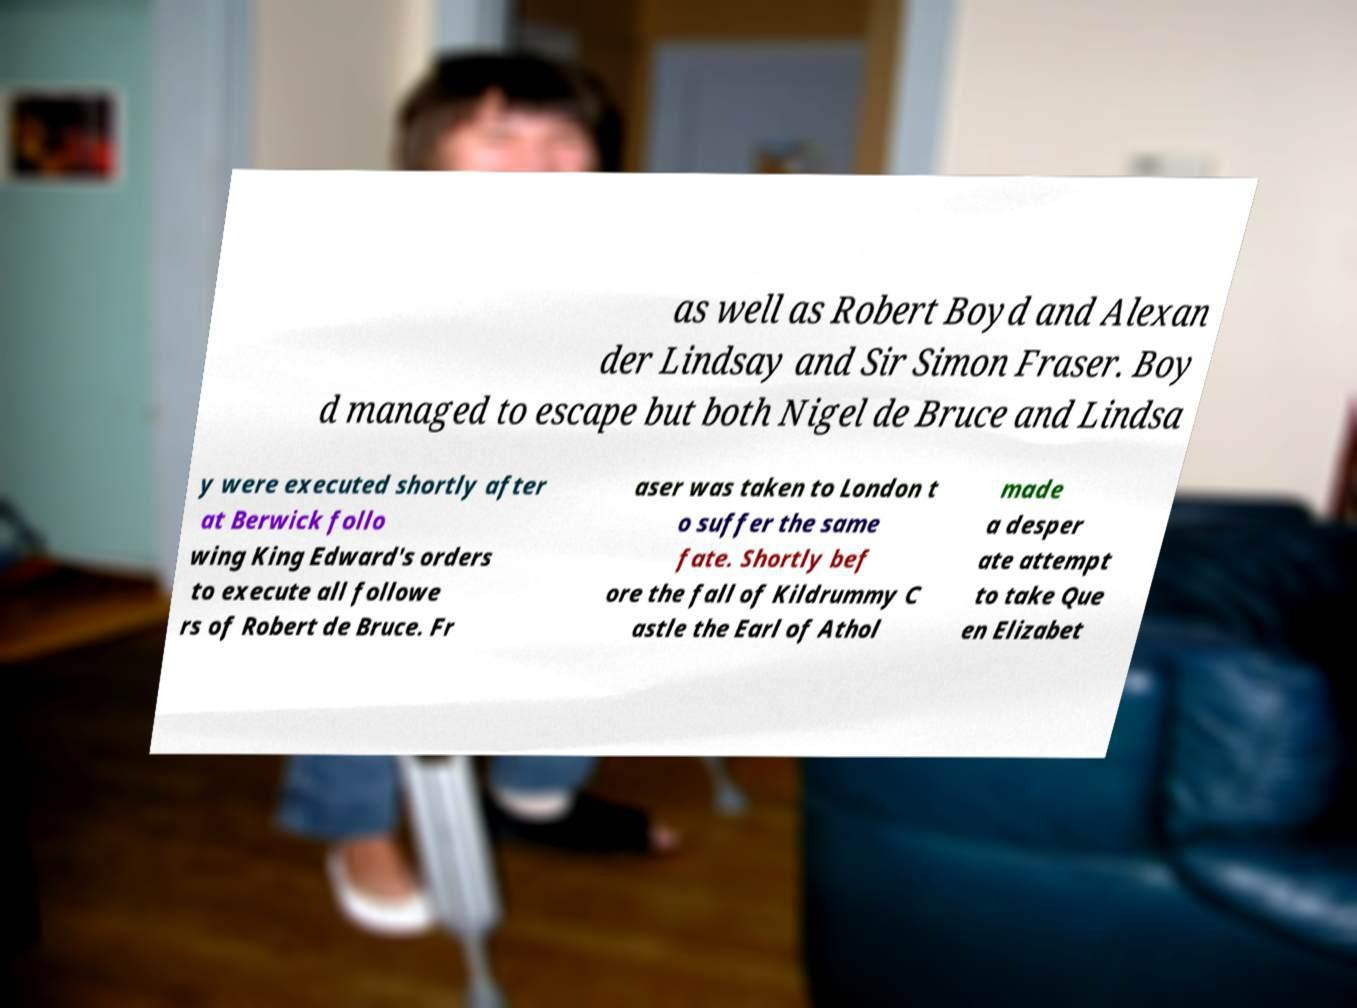Please identify and transcribe the text found in this image. as well as Robert Boyd and Alexan der Lindsay and Sir Simon Fraser. Boy d managed to escape but both Nigel de Bruce and Lindsa y were executed shortly after at Berwick follo wing King Edward's orders to execute all followe rs of Robert de Bruce. Fr aser was taken to London t o suffer the same fate. Shortly bef ore the fall of Kildrummy C astle the Earl of Athol made a desper ate attempt to take Que en Elizabet 